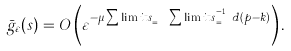<formula> <loc_0><loc_0><loc_500><loc_500>\bar { g } _ { \varepsilon } ( s ) = O \left ( \varepsilon ^ { - \mu \sum \lim i t s _ { p = l } ^ { j } \sum \lim i t s _ { k = l } ^ { p - 1 } d ( p - k ) } \right ) .</formula> 